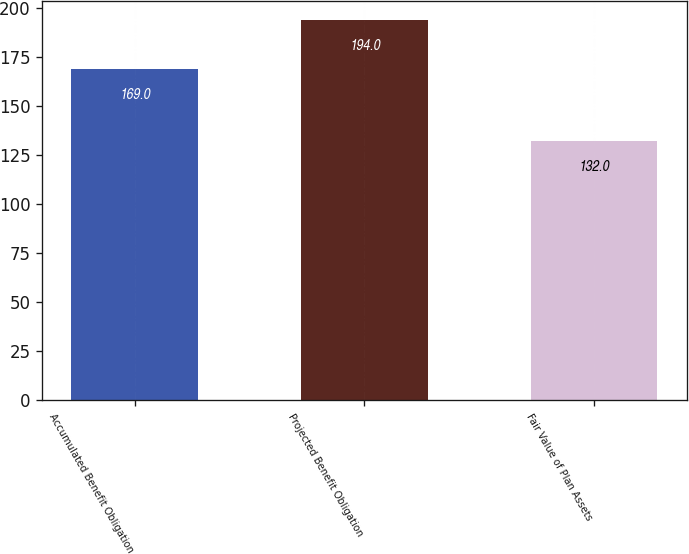Convert chart to OTSL. <chart><loc_0><loc_0><loc_500><loc_500><bar_chart><fcel>Accumulated Benefit Obligation<fcel>Projected Benefit Obligation<fcel>Fair Value of Plan Assets<nl><fcel>169<fcel>194<fcel>132<nl></chart> 